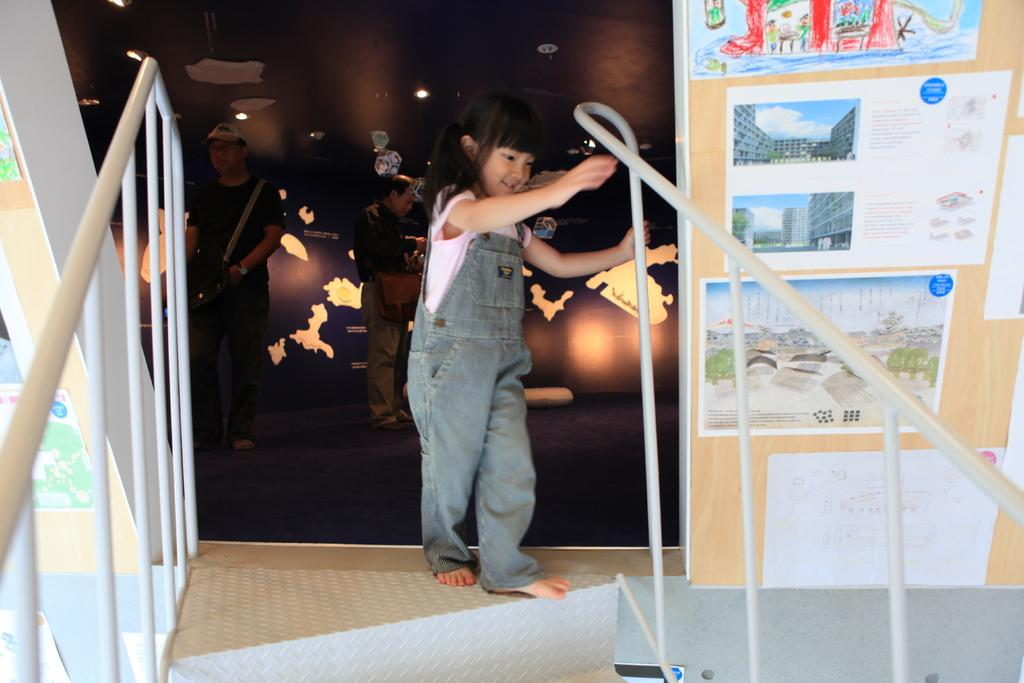Who is the main subject in the image? There is a girl in the image. What is the girl holding in the image? The girl is holding a rod. What can be seen in the background of the image? There are railings, posters, and a wall in the image. Are there any other people in the image besides the girl? Yes, there are people in the image. What type of lighting is present in the image? There are lights in the image. What type of sock is the girl wearing in the image? There is no information about the girl's socks in the image, so it cannot be determined. 